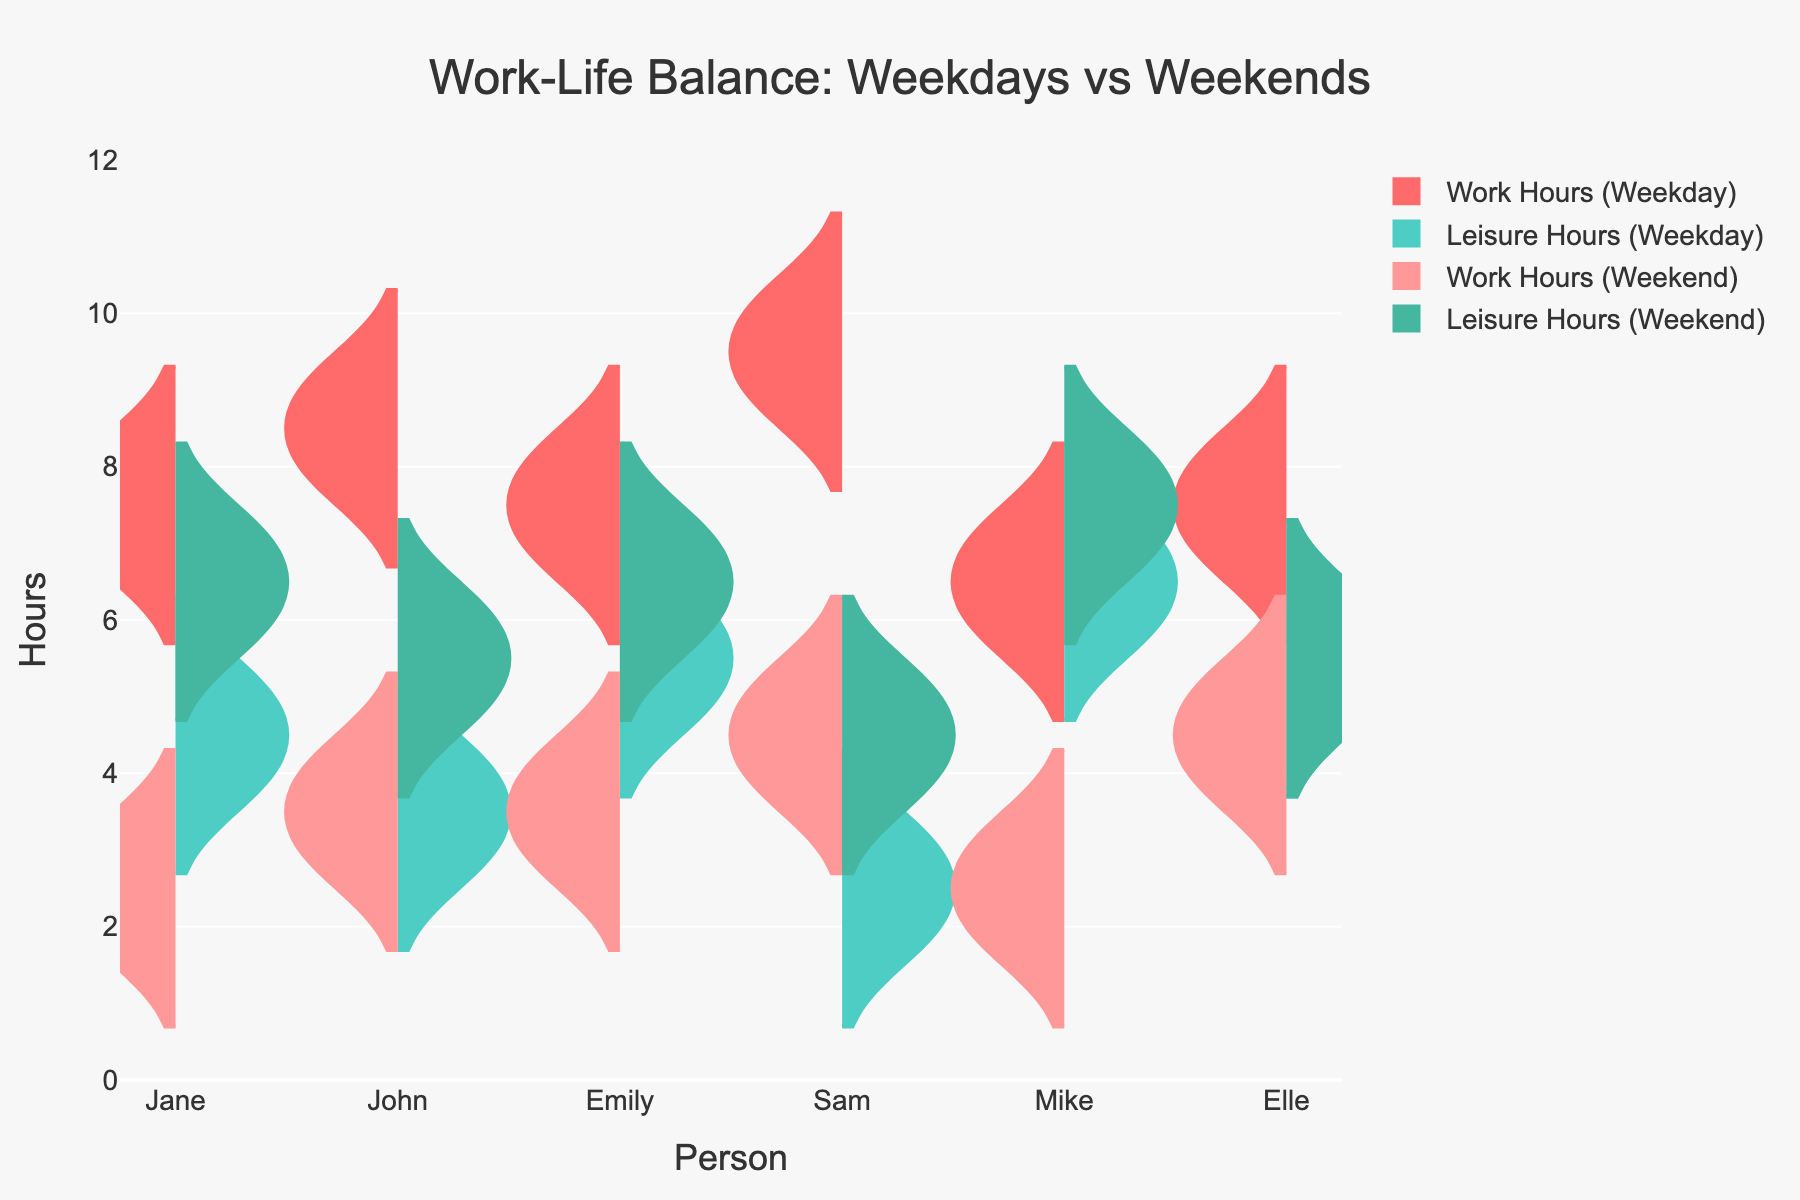What is the title of the figure? The title is displayed at the top of the figure, usually in a larger font and bold style. It gives an overview of what the data represents, indicating the scope or the main subject of the data shown.
Answer: Work-Life Balance: Weekdays vs Weekends What is the range of the y-axis? The range of the y-axis is identified by looking at the minimum and maximum values on the vertical axis. This includes all the labels between those points.
Answer: 0 to 12 Which person has the highest median work hours on weekdays? To determine this, observe the position of the violin plots for work hours on weekdays and find the person with the violin plot that extends highest on the negative side of the y-axis.
Answer: Sam Which person has the highest median leisure hours on weekends? Observe the violin plots for leisure hours on weekends and note which violin plot extends highest on the positive side of the y-axis, indicating the highest median value.
Answer: Mike How do John’s work hours on weekdays compare to his work hours on weekends? Compare John's weekday work hours violin plot (negative side) with his weekend work hours violin plot (negative side). Look at the typical heights and spread of these plots.
Answer: Higher on weekdays Compare Emily’s leisure hours on weekends with her leisure hours on weekdays. Look at the violin plots for Emily's leisure hours on both weekdays and weekends (positive side). Compare the heights and spread to understand the difference.
Answer: Higher on weekends Which person has the smallest difference between weekday and weekend leisure hours? Look at all the violin plots’ positive sides for each person and compare the heights and spread between weekdays and weekends. The person with the smallest variation is the answer.
Answer: Elle On weekdays, who has more leisure hours, Jane or Mike? Compare Jane's and Mike's weekday leisure hours violin plots on the positive side. The one with the higher plot indicates more hours.
Answer: Mike What is the typical range of leisure hours during weekends for Jane? Look at the violin plot for Jane’s leisure hours on the weekends (positive side) and observe the span of the plot to determine the range.
Answer: 6 to 7 hours 